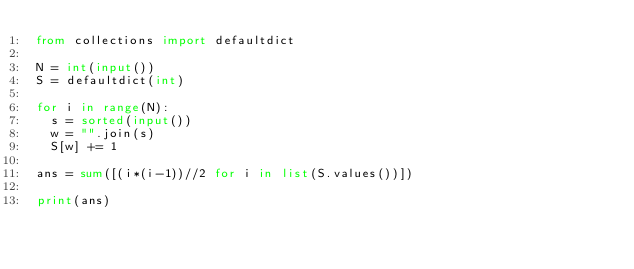<code> <loc_0><loc_0><loc_500><loc_500><_Python_>from collections import defaultdict

N = int(input())
S = defaultdict(int)

for i in range(N):
  s = sorted(input())
  w = "".join(s)
  S[w] += 1

ans = sum([(i*(i-1))//2 for i in list(S.values())])

print(ans)</code> 